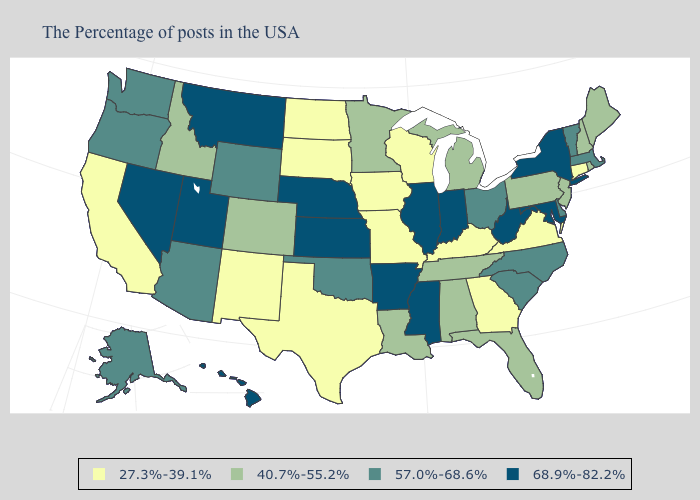Does Georgia have a lower value than Nevada?
Concise answer only. Yes. Does the first symbol in the legend represent the smallest category?
Be succinct. Yes. What is the value of Michigan?
Be succinct. 40.7%-55.2%. Among the states that border Utah , does Arizona have the lowest value?
Concise answer only. No. Among the states that border North Dakota , does South Dakota have the highest value?
Quick response, please. No. Does Virginia have the lowest value in the USA?
Concise answer only. Yes. Which states have the lowest value in the USA?
Write a very short answer. Connecticut, Virginia, Georgia, Kentucky, Wisconsin, Missouri, Iowa, Texas, South Dakota, North Dakota, New Mexico, California. Does the first symbol in the legend represent the smallest category?
Keep it brief. Yes. What is the value of Kansas?
Keep it brief. 68.9%-82.2%. Name the states that have a value in the range 57.0%-68.6%?
Concise answer only. Massachusetts, Vermont, Delaware, North Carolina, South Carolina, Ohio, Oklahoma, Wyoming, Arizona, Washington, Oregon, Alaska. Name the states that have a value in the range 40.7%-55.2%?
Keep it brief. Maine, Rhode Island, New Hampshire, New Jersey, Pennsylvania, Florida, Michigan, Alabama, Tennessee, Louisiana, Minnesota, Colorado, Idaho. What is the lowest value in the South?
Quick response, please. 27.3%-39.1%. What is the value of North Carolina?
Give a very brief answer. 57.0%-68.6%. Name the states that have a value in the range 57.0%-68.6%?
Write a very short answer. Massachusetts, Vermont, Delaware, North Carolina, South Carolina, Ohio, Oklahoma, Wyoming, Arizona, Washington, Oregon, Alaska. What is the lowest value in the South?
Answer briefly. 27.3%-39.1%. 